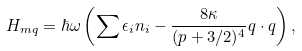<formula> <loc_0><loc_0><loc_500><loc_500>H _ { m q } = \hbar { \omega } \left ( \sum \epsilon _ { i } n _ { i } - \frac { 8 \kappa } { ( p + 3 / 2 ) ^ { 4 } } q \cdot q \right ) ,</formula> 